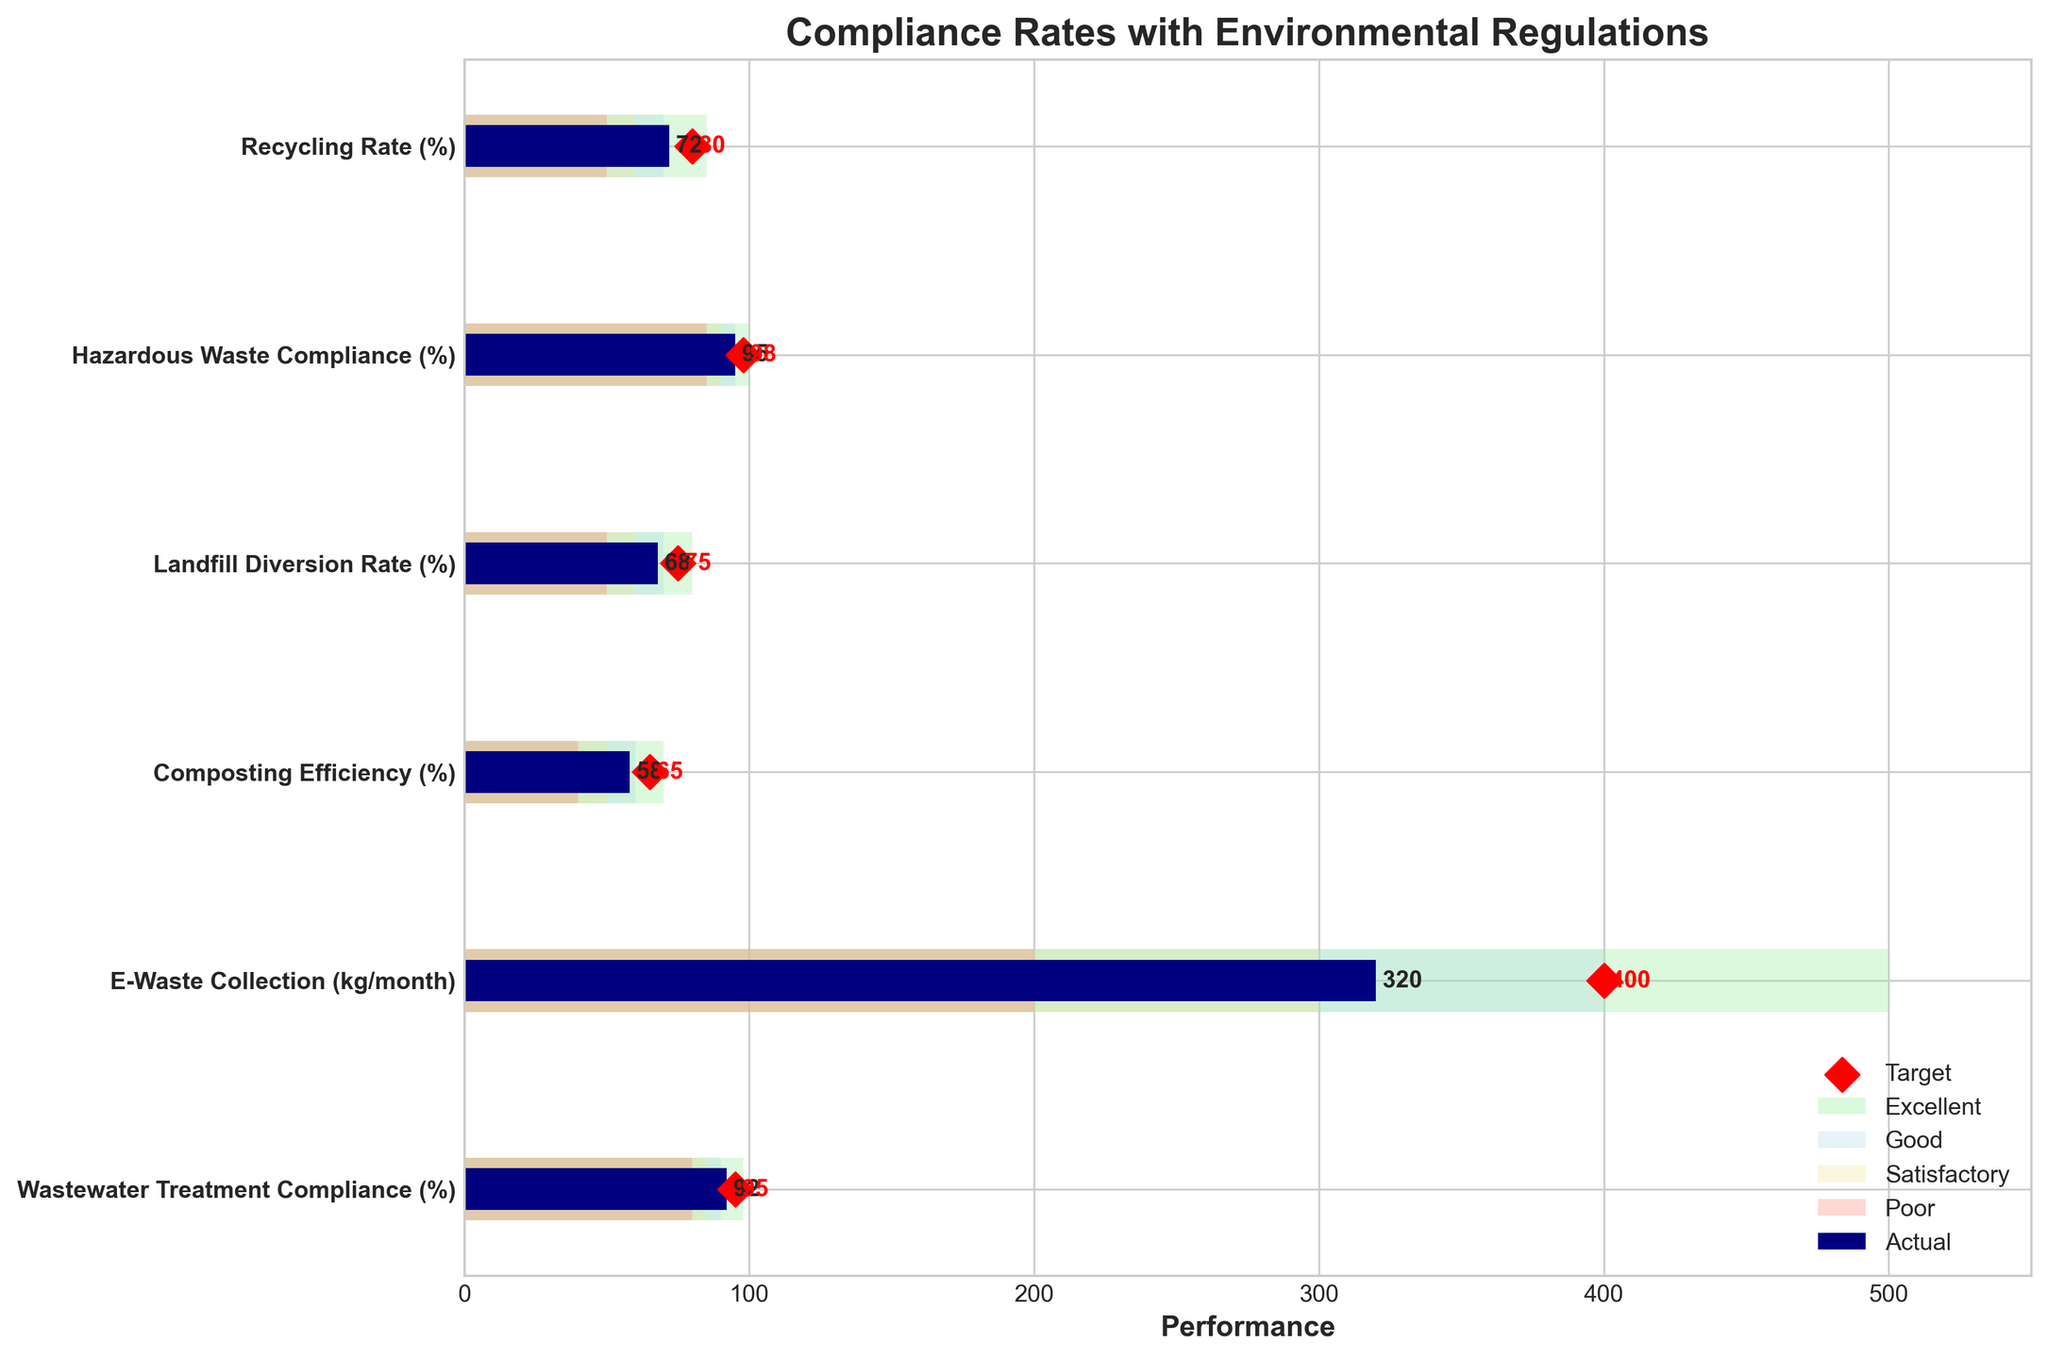What is the actual recycling rate in the figure? The actual recycling rate can be found in the "Actual" bar for "Recycling Rate (%)"
Answer: 72% Which metric has the highest actual value? By comparing the "Actual" values of all metrics, "Hazardous Waste Compliance (%)" has the highest actual value
Answer: Hazardous Waste Compliance (%) How many metrics have an actual value above their satisfactory level? Count the metrics where the actual value is higher than the satisfactory level. "Recycling Rate (%)" (72 > 60), "Hazardous Waste Compliance (%)" (95 > 90), "E-Waste Collection (kg/month)" (320 > 300), and "Wastewater Treatment Compliance (%)" (92 > 85)
Answer: 4 By how much does the composting efficiency fall short of its target? Subtract the actual value of composting efficiency from its target: 65 - 58
Answer: 7 Which metric has the smallest difference between the actual value and the target value? Calculate the absolute differences between the actual and target values for each metric: "Recycling Rate (%)" (8), "Hazardous Waste Compliance (%)" (3), "Landfill Diversion Rate (%)" (7), "Composting Efficiency (%)" (7), "E-Waste Collection (kg/month)" (80), "Wastewater Treatment Compliance (%)" (3). The smallest difference is for "Hazardous Waste Compliance (%)" and "Wastewater Treatment Compliance (%)"
Answer: Hazardous Waste Compliance (%) and Wastewater Treatment Compliance (%) Which metric has the widest range for excellent performance? Compare the ranges specified for excellent performance: "Recycling Rate (%)" (85-70 = 15), "Hazardous Waste Compliance (%)" (100-95 = 5), "Landfill Diversion Rate (%)" (80-70 = 10), "Composting Efficiency (%)" (70-60 = 10), "E-Waste Collection (kg/month)" (500-400 = 100), "Wastewater Treatment Compliance (%)" (98-90 = 8)
Answer: E-Waste Collection (kg/month) How many metrics surpass the "Good" threshold but are below their target? Identify metrics where actual values are higher than the "Good" level but lower than the target. Only "E-Waste Collection (kg/month)" (320) fits this condition, where 320 > 300 (Good) but < 400 (Target)
Answer: 1 What is the average target value for all the metrics? Sum all target values and divide by the number of metrics: (80 + 98 + 75 + 65 + 400 + 95)/6 = 1365/6
Answer: 227.5 Which metric's actual value is closest to its poor range? Compare actual values with poor ranges and find the metric with the smallest difference. "Composting Efficiency (%)" has its actual value (58) closest to its poor range (40) with a difference of 18
Answer: Composting Efficiency (%) Between which two metrics is there the largest gap in their satisfactory range? Identify satisfactory ranges and compare: "Recycling Rate (%)" (60), "Hazardous Waste Compliance (%)" (90), "Landfill Diversion Rate (%)" (60), "Composting Efficiency (%)" (50), "E-Waste Collection (kg/month)" (300), "Wastewater Treatment Compliance (%)" (85). The largest gap is between "E-Waste Collection (kg/month)" (300) and any of the other satisfactory ranges, with the largest difference being between "E-Waste Collection" and "Composting Efficiency %" (300 - 50 = 250)
Answer: E-Waste Collection and Composting Efficiency (%) 